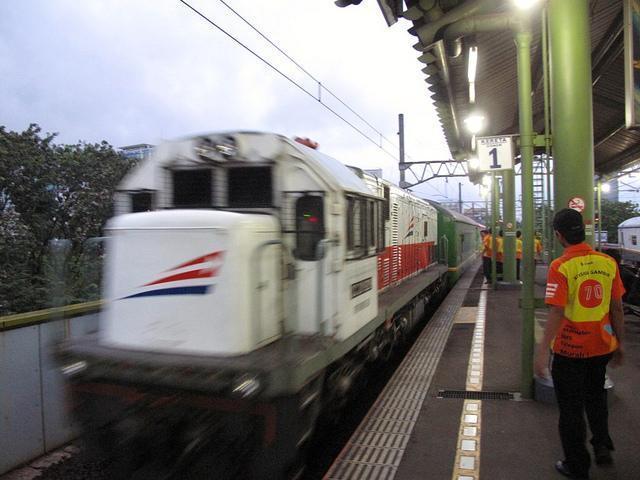How many wheels does the bike on the right have?
Give a very brief answer. 0. 